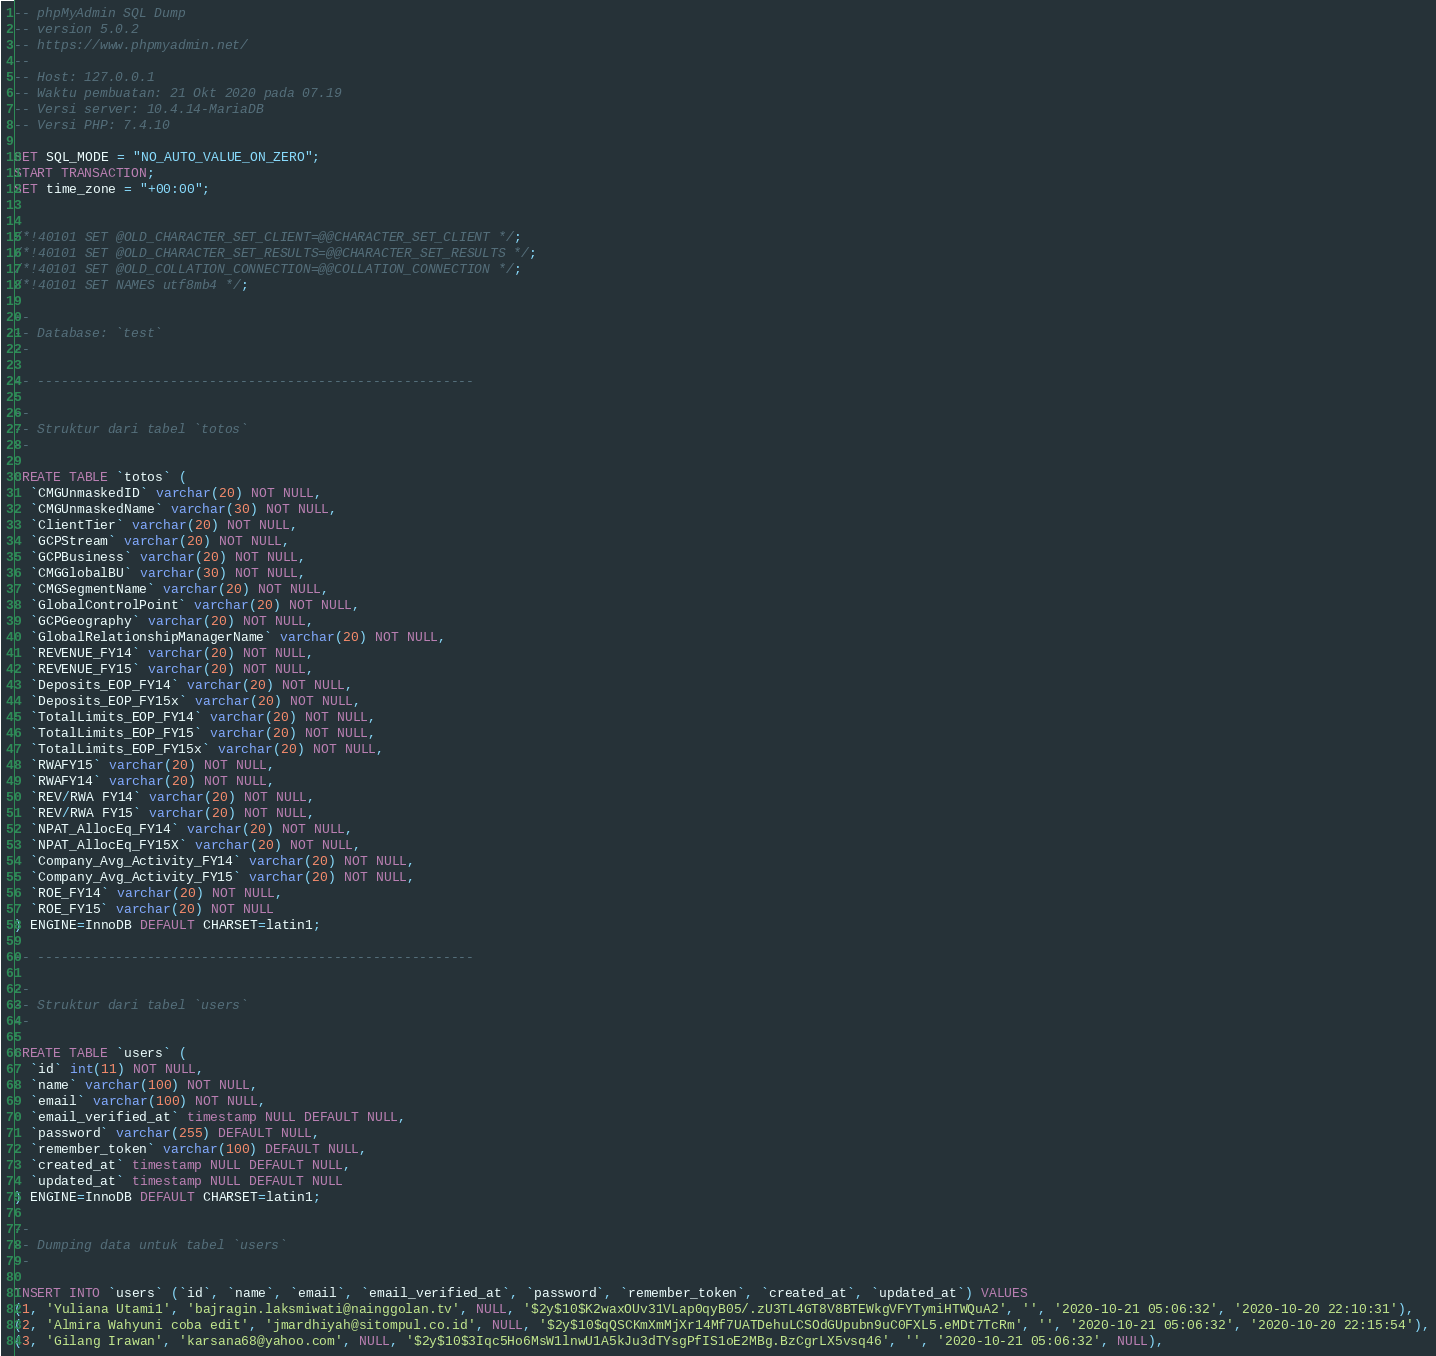<code> <loc_0><loc_0><loc_500><loc_500><_SQL_>-- phpMyAdmin SQL Dump
-- version 5.0.2
-- https://www.phpmyadmin.net/
--
-- Host: 127.0.0.1
-- Waktu pembuatan: 21 Okt 2020 pada 07.19
-- Versi server: 10.4.14-MariaDB
-- Versi PHP: 7.4.10

SET SQL_MODE = "NO_AUTO_VALUE_ON_ZERO";
START TRANSACTION;
SET time_zone = "+00:00";


/*!40101 SET @OLD_CHARACTER_SET_CLIENT=@@CHARACTER_SET_CLIENT */;
/*!40101 SET @OLD_CHARACTER_SET_RESULTS=@@CHARACTER_SET_RESULTS */;
/*!40101 SET @OLD_COLLATION_CONNECTION=@@COLLATION_CONNECTION */;
/*!40101 SET NAMES utf8mb4 */;

--
-- Database: `test`
--

-- --------------------------------------------------------

--
-- Struktur dari tabel `totos`
--

CREATE TABLE `totos` (
  `CMGUnmaskedID` varchar(20) NOT NULL,
  `CMGUnmaskedName` varchar(30) NOT NULL,
  `ClientTier` varchar(20) NOT NULL,
  `GCPStream` varchar(20) NOT NULL,
  `GCPBusiness` varchar(20) NOT NULL,
  `CMGGlobalBU` varchar(30) NOT NULL,
  `CMGSegmentName` varchar(20) NOT NULL,
  `GlobalControlPoint` varchar(20) NOT NULL,
  `GCPGeography` varchar(20) NOT NULL,
  `GlobalRelationshipManagerName` varchar(20) NOT NULL,
  `REVENUE_FY14` varchar(20) NOT NULL,
  `REVENUE_FY15` varchar(20) NOT NULL,
  `Deposits_EOP_FY14` varchar(20) NOT NULL,
  `Deposits_EOP_FY15x` varchar(20) NOT NULL,
  `TotalLimits_EOP_FY14` varchar(20) NOT NULL,
  `TotalLimits_EOP_FY15` varchar(20) NOT NULL,
  `TotalLimits_EOP_FY15x` varchar(20) NOT NULL,
  `RWAFY15` varchar(20) NOT NULL,
  `RWAFY14` varchar(20) NOT NULL,
  `REV/RWA FY14` varchar(20) NOT NULL,
  `REV/RWA FY15` varchar(20) NOT NULL,
  `NPAT_AllocEq_FY14` varchar(20) NOT NULL,
  `NPAT_AllocEq_FY15X` varchar(20) NOT NULL,
  `Company_Avg_Activity_FY14` varchar(20) NOT NULL,
  `Company_Avg_Activity_FY15` varchar(20) NOT NULL,
  `ROE_FY14` varchar(20) NOT NULL,
  `ROE_FY15` varchar(20) NOT NULL
) ENGINE=InnoDB DEFAULT CHARSET=latin1;

-- --------------------------------------------------------

--
-- Struktur dari tabel `users`
--

CREATE TABLE `users` (
  `id` int(11) NOT NULL,
  `name` varchar(100) NOT NULL,
  `email` varchar(100) NOT NULL,
  `email_verified_at` timestamp NULL DEFAULT NULL,
  `password` varchar(255) DEFAULT NULL,
  `remember_token` varchar(100) DEFAULT NULL,
  `created_at` timestamp NULL DEFAULT NULL,
  `updated_at` timestamp NULL DEFAULT NULL
) ENGINE=InnoDB DEFAULT CHARSET=latin1;

--
-- Dumping data untuk tabel `users`
--

INSERT INTO `users` (`id`, `name`, `email`, `email_verified_at`, `password`, `remember_token`, `created_at`, `updated_at`) VALUES
(1, 'Yuliana Utami1', 'bajragin.laksmiwati@nainggolan.tv', NULL, '$2y$10$K2waxOUv31VLap0qyB05/.zU3TL4GT8V8BTEWkgVFYTymiHTWQuA2', '', '2020-10-21 05:06:32', '2020-10-20 22:10:31'),
(2, 'Almira Wahyuni coba edit', 'jmardhiyah@sitompul.co.id', NULL, '$2y$10$qQSCKmXmMjXr14Mf7UATDehuLCSOdGUpubn9uC0FXL5.eMDt7TcRm', '', '2020-10-21 05:06:32', '2020-10-20 22:15:54'),
(3, 'Gilang Irawan', 'karsana68@yahoo.com', NULL, '$2y$10$3Iqc5Ho6MsW1lnwU1A5kJu3dTYsgPfIS1oE2MBg.BzCgrLX5vsq46', '', '2020-10-21 05:06:32', NULL),</code> 